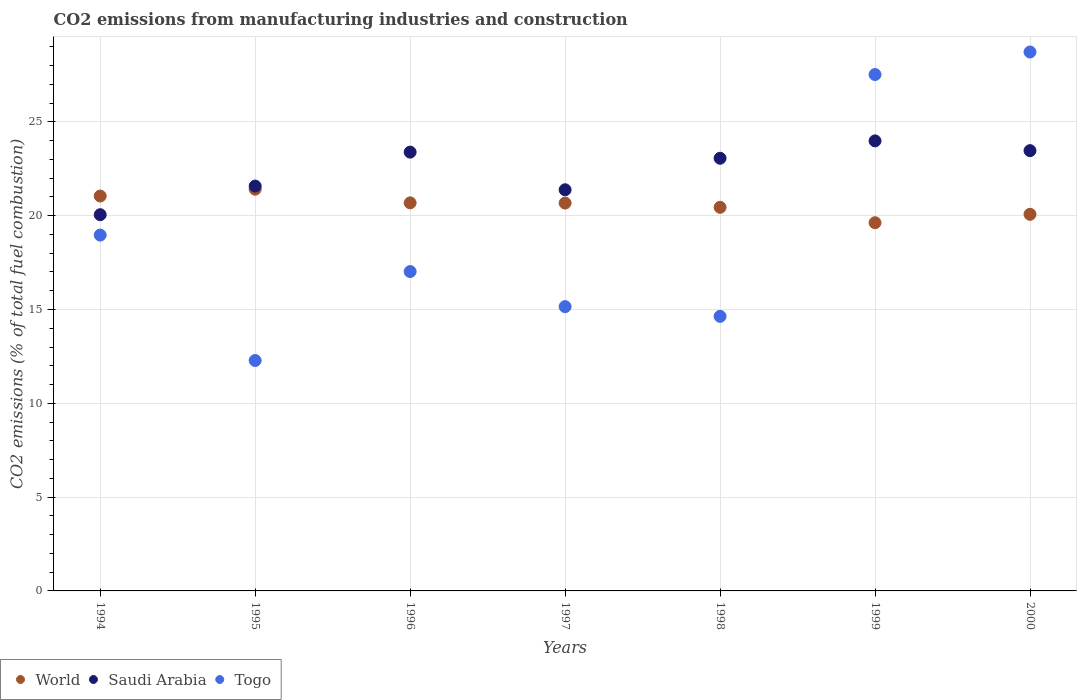What is the amount of CO2 emitted in Saudi Arabia in 1997?
Offer a terse response. 21.38. Across all years, what is the maximum amount of CO2 emitted in World?
Your answer should be very brief. 21.41. Across all years, what is the minimum amount of CO2 emitted in Saudi Arabia?
Your answer should be compact. 20.05. What is the total amount of CO2 emitted in Togo in the graph?
Make the answer very short. 134.3. What is the difference between the amount of CO2 emitted in Saudi Arabia in 1995 and that in 1997?
Your response must be concise. 0.2. What is the difference between the amount of CO2 emitted in Saudi Arabia in 1995 and the amount of CO2 emitted in World in 1999?
Ensure brevity in your answer.  1.95. What is the average amount of CO2 emitted in World per year?
Make the answer very short. 20.56. In the year 1997, what is the difference between the amount of CO2 emitted in Saudi Arabia and amount of CO2 emitted in Togo?
Ensure brevity in your answer.  6.23. In how many years, is the amount of CO2 emitted in Togo greater than 4 %?
Your answer should be compact. 7. What is the ratio of the amount of CO2 emitted in World in 1994 to that in 1997?
Keep it short and to the point. 1.02. Is the amount of CO2 emitted in Saudi Arabia in 1997 less than that in 2000?
Provide a short and direct response. Yes. What is the difference between the highest and the second highest amount of CO2 emitted in Saudi Arabia?
Your response must be concise. 0.52. What is the difference between the highest and the lowest amount of CO2 emitted in World?
Provide a succinct answer. 1.79. Is the sum of the amount of CO2 emitted in Togo in 1994 and 1997 greater than the maximum amount of CO2 emitted in Saudi Arabia across all years?
Provide a short and direct response. Yes. Is the amount of CO2 emitted in Togo strictly less than the amount of CO2 emitted in World over the years?
Your response must be concise. No. How many dotlines are there?
Your answer should be compact. 3. What is the difference between two consecutive major ticks on the Y-axis?
Your response must be concise. 5. Are the values on the major ticks of Y-axis written in scientific E-notation?
Your answer should be very brief. No. Does the graph contain grids?
Your response must be concise. Yes. Where does the legend appear in the graph?
Offer a very short reply. Bottom left. How many legend labels are there?
Your answer should be compact. 3. What is the title of the graph?
Offer a terse response. CO2 emissions from manufacturing industries and construction. What is the label or title of the Y-axis?
Offer a terse response. CO2 emissions (% of total fuel combustion). What is the CO2 emissions (% of total fuel combustion) in World in 1994?
Make the answer very short. 21.05. What is the CO2 emissions (% of total fuel combustion) in Saudi Arabia in 1994?
Your response must be concise. 20.05. What is the CO2 emissions (% of total fuel combustion) of Togo in 1994?
Your response must be concise. 18.97. What is the CO2 emissions (% of total fuel combustion) of World in 1995?
Provide a succinct answer. 21.41. What is the CO2 emissions (% of total fuel combustion) of Saudi Arabia in 1995?
Your response must be concise. 21.58. What is the CO2 emissions (% of total fuel combustion) of Togo in 1995?
Give a very brief answer. 12.28. What is the CO2 emissions (% of total fuel combustion) of World in 1996?
Your answer should be very brief. 20.68. What is the CO2 emissions (% of total fuel combustion) of Saudi Arabia in 1996?
Ensure brevity in your answer.  23.39. What is the CO2 emissions (% of total fuel combustion) in Togo in 1996?
Give a very brief answer. 17.02. What is the CO2 emissions (% of total fuel combustion) of World in 1997?
Your response must be concise. 20.67. What is the CO2 emissions (% of total fuel combustion) in Saudi Arabia in 1997?
Keep it short and to the point. 21.38. What is the CO2 emissions (% of total fuel combustion) in Togo in 1997?
Provide a short and direct response. 15.15. What is the CO2 emissions (% of total fuel combustion) in World in 1998?
Give a very brief answer. 20.45. What is the CO2 emissions (% of total fuel combustion) of Saudi Arabia in 1998?
Ensure brevity in your answer.  23.06. What is the CO2 emissions (% of total fuel combustion) of Togo in 1998?
Keep it short and to the point. 14.63. What is the CO2 emissions (% of total fuel combustion) in World in 1999?
Ensure brevity in your answer.  19.62. What is the CO2 emissions (% of total fuel combustion) in Saudi Arabia in 1999?
Make the answer very short. 23.99. What is the CO2 emissions (% of total fuel combustion) in Togo in 1999?
Provide a short and direct response. 27.52. What is the CO2 emissions (% of total fuel combustion) of World in 2000?
Your answer should be compact. 20.07. What is the CO2 emissions (% of total fuel combustion) of Saudi Arabia in 2000?
Provide a succinct answer. 23.47. What is the CO2 emissions (% of total fuel combustion) in Togo in 2000?
Provide a short and direct response. 28.72. Across all years, what is the maximum CO2 emissions (% of total fuel combustion) in World?
Your response must be concise. 21.41. Across all years, what is the maximum CO2 emissions (% of total fuel combustion) of Saudi Arabia?
Provide a succinct answer. 23.99. Across all years, what is the maximum CO2 emissions (% of total fuel combustion) in Togo?
Your response must be concise. 28.72. Across all years, what is the minimum CO2 emissions (% of total fuel combustion) of World?
Your answer should be very brief. 19.62. Across all years, what is the minimum CO2 emissions (% of total fuel combustion) of Saudi Arabia?
Provide a succinct answer. 20.05. Across all years, what is the minimum CO2 emissions (% of total fuel combustion) in Togo?
Your answer should be very brief. 12.28. What is the total CO2 emissions (% of total fuel combustion) of World in the graph?
Your answer should be compact. 143.95. What is the total CO2 emissions (% of total fuel combustion) in Saudi Arabia in the graph?
Give a very brief answer. 156.91. What is the total CO2 emissions (% of total fuel combustion) of Togo in the graph?
Ensure brevity in your answer.  134.3. What is the difference between the CO2 emissions (% of total fuel combustion) of World in 1994 and that in 1995?
Your answer should be compact. -0.36. What is the difference between the CO2 emissions (% of total fuel combustion) of Saudi Arabia in 1994 and that in 1995?
Offer a terse response. -1.53. What is the difference between the CO2 emissions (% of total fuel combustion) of Togo in 1994 and that in 1995?
Provide a succinct answer. 6.68. What is the difference between the CO2 emissions (% of total fuel combustion) of World in 1994 and that in 1996?
Give a very brief answer. 0.36. What is the difference between the CO2 emissions (% of total fuel combustion) of Saudi Arabia in 1994 and that in 1996?
Your response must be concise. -3.34. What is the difference between the CO2 emissions (% of total fuel combustion) in Togo in 1994 and that in 1996?
Ensure brevity in your answer.  1.94. What is the difference between the CO2 emissions (% of total fuel combustion) of World in 1994 and that in 1997?
Offer a very short reply. 0.37. What is the difference between the CO2 emissions (% of total fuel combustion) in Saudi Arabia in 1994 and that in 1997?
Your response must be concise. -1.33. What is the difference between the CO2 emissions (% of total fuel combustion) in Togo in 1994 and that in 1997?
Provide a succinct answer. 3.81. What is the difference between the CO2 emissions (% of total fuel combustion) of World in 1994 and that in 1998?
Provide a succinct answer. 0.6. What is the difference between the CO2 emissions (% of total fuel combustion) in Saudi Arabia in 1994 and that in 1998?
Provide a short and direct response. -3.01. What is the difference between the CO2 emissions (% of total fuel combustion) in Togo in 1994 and that in 1998?
Provide a short and direct response. 4.33. What is the difference between the CO2 emissions (% of total fuel combustion) in World in 1994 and that in 1999?
Offer a terse response. 1.42. What is the difference between the CO2 emissions (% of total fuel combustion) of Saudi Arabia in 1994 and that in 1999?
Offer a terse response. -3.93. What is the difference between the CO2 emissions (% of total fuel combustion) of Togo in 1994 and that in 1999?
Your answer should be compact. -8.56. What is the difference between the CO2 emissions (% of total fuel combustion) in Saudi Arabia in 1994 and that in 2000?
Keep it short and to the point. -3.41. What is the difference between the CO2 emissions (% of total fuel combustion) of Togo in 1994 and that in 2000?
Provide a succinct answer. -9.76. What is the difference between the CO2 emissions (% of total fuel combustion) of World in 1995 and that in 1996?
Your response must be concise. 0.73. What is the difference between the CO2 emissions (% of total fuel combustion) in Saudi Arabia in 1995 and that in 1996?
Ensure brevity in your answer.  -1.81. What is the difference between the CO2 emissions (% of total fuel combustion) in Togo in 1995 and that in 1996?
Provide a short and direct response. -4.74. What is the difference between the CO2 emissions (% of total fuel combustion) in World in 1995 and that in 1997?
Offer a terse response. 0.74. What is the difference between the CO2 emissions (% of total fuel combustion) in Saudi Arabia in 1995 and that in 1997?
Ensure brevity in your answer.  0.2. What is the difference between the CO2 emissions (% of total fuel combustion) in Togo in 1995 and that in 1997?
Your response must be concise. -2.87. What is the difference between the CO2 emissions (% of total fuel combustion) of World in 1995 and that in 1998?
Your answer should be compact. 0.96. What is the difference between the CO2 emissions (% of total fuel combustion) in Saudi Arabia in 1995 and that in 1998?
Your answer should be very brief. -1.48. What is the difference between the CO2 emissions (% of total fuel combustion) in Togo in 1995 and that in 1998?
Provide a succinct answer. -2.35. What is the difference between the CO2 emissions (% of total fuel combustion) of World in 1995 and that in 1999?
Provide a short and direct response. 1.79. What is the difference between the CO2 emissions (% of total fuel combustion) of Saudi Arabia in 1995 and that in 1999?
Make the answer very short. -2.41. What is the difference between the CO2 emissions (% of total fuel combustion) in Togo in 1995 and that in 1999?
Provide a short and direct response. -15.24. What is the difference between the CO2 emissions (% of total fuel combustion) in World in 1995 and that in 2000?
Offer a very short reply. 1.34. What is the difference between the CO2 emissions (% of total fuel combustion) of Saudi Arabia in 1995 and that in 2000?
Provide a short and direct response. -1.89. What is the difference between the CO2 emissions (% of total fuel combustion) in Togo in 1995 and that in 2000?
Give a very brief answer. -16.44. What is the difference between the CO2 emissions (% of total fuel combustion) in World in 1996 and that in 1997?
Offer a very short reply. 0.01. What is the difference between the CO2 emissions (% of total fuel combustion) in Saudi Arabia in 1996 and that in 1997?
Provide a short and direct response. 2.01. What is the difference between the CO2 emissions (% of total fuel combustion) of Togo in 1996 and that in 1997?
Provide a short and direct response. 1.87. What is the difference between the CO2 emissions (% of total fuel combustion) in World in 1996 and that in 1998?
Offer a very short reply. 0.24. What is the difference between the CO2 emissions (% of total fuel combustion) of Saudi Arabia in 1996 and that in 1998?
Offer a terse response. 0.33. What is the difference between the CO2 emissions (% of total fuel combustion) in Togo in 1996 and that in 1998?
Give a very brief answer. 2.39. What is the difference between the CO2 emissions (% of total fuel combustion) in World in 1996 and that in 1999?
Your response must be concise. 1.06. What is the difference between the CO2 emissions (% of total fuel combustion) in Saudi Arabia in 1996 and that in 1999?
Offer a terse response. -0.6. What is the difference between the CO2 emissions (% of total fuel combustion) in Togo in 1996 and that in 1999?
Offer a very short reply. -10.5. What is the difference between the CO2 emissions (% of total fuel combustion) in World in 1996 and that in 2000?
Your answer should be compact. 0.61. What is the difference between the CO2 emissions (% of total fuel combustion) of Saudi Arabia in 1996 and that in 2000?
Ensure brevity in your answer.  -0.08. What is the difference between the CO2 emissions (% of total fuel combustion) in Togo in 1996 and that in 2000?
Keep it short and to the point. -11.7. What is the difference between the CO2 emissions (% of total fuel combustion) in World in 1997 and that in 1998?
Make the answer very short. 0.23. What is the difference between the CO2 emissions (% of total fuel combustion) in Saudi Arabia in 1997 and that in 1998?
Make the answer very short. -1.68. What is the difference between the CO2 emissions (% of total fuel combustion) in Togo in 1997 and that in 1998?
Keep it short and to the point. 0.52. What is the difference between the CO2 emissions (% of total fuel combustion) of World in 1997 and that in 1999?
Offer a very short reply. 1.05. What is the difference between the CO2 emissions (% of total fuel combustion) in Saudi Arabia in 1997 and that in 1999?
Your answer should be very brief. -2.61. What is the difference between the CO2 emissions (% of total fuel combustion) in Togo in 1997 and that in 1999?
Provide a succinct answer. -12.37. What is the difference between the CO2 emissions (% of total fuel combustion) in World in 1997 and that in 2000?
Your response must be concise. 0.6. What is the difference between the CO2 emissions (% of total fuel combustion) in Saudi Arabia in 1997 and that in 2000?
Provide a short and direct response. -2.09. What is the difference between the CO2 emissions (% of total fuel combustion) of Togo in 1997 and that in 2000?
Make the answer very short. -13.57. What is the difference between the CO2 emissions (% of total fuel combustion) of World in 1998 and that in 1999?
Make the answer very short. 0.82. What is the difference between the CO2 emissions (% of total fuel combustion) of Saudi Arabia in 1998 and that in 1999?
Your answer should be very brief. -0.93. What is the difference between the CO2 emissions (% of total fuel combustion) in Togo in 1998 and that in 1999?
Ensure brevity in your answer.  -12.89. What is the difference between the CO2 emissions (% of total fuel combustion) in World in 1998 and that in 2000?
Your response must be concise. 0.37. What is the difference between the CO2 emissions (% of total fuel combustion) of Saudi Arabia in 1998 and that in 2000?
Your answer should be compact. -0.41. What is the difference between the CO2 emissions (% of total fuel combustion) in Togo in 1998 and that in 2000?
Your response must be concise. -14.09. What is the difference between the CO2 emissions (% of total fuel combustion) in World in 1999 and that in 2000?
Offer a very short reply. -0.45. What is the difference between the CO2 emissions (% of total fuel combustion) in Saudi Arabia in 1999 and that in 2000?
Your answer should be very brief. 0.52. What is the difference between the CO2 emissions (% of total fuel combustion) of Togo in 1999 and that in 2000?
Offer a terse response. -1.2. What is the difference between the CO2 emissions (% of total fuel combustion) of World in 1994 and the CO2 emissions (% of total fuel combustion) of Saudi Arabia in 1995?
Provide a short and direct response. -0.53. What is the difference between the CO2 emissions (% of total fuel combustion) of World in 1994 and the CO2 emissions (% of total fuel combustion) of Togo in 1995?
Offer a very short reply. 8.77. What is the difference between the CO2 emissions (% of total fuel combustion) in Saudi Arabia in 1994 and the CO2 emissions (% of total fuel combustion) in Togo in 1995?
Make the answer very short. 7.77. What is the difference between the CO2 emissions (% of total fuel combustion) in World in 1994 and the CO2 emissions (% of total fuel combustion) in Saudi Arabia in 1996?
Your response must be concise. -2.34. What is the difference between the CO2 emissions (% of total fuel combustion) of World in 1994 and the CO2 emissions (% of total fuel combustion) of Togo in 1996?
Provide a succinct answer. 4.02. What is the difference between the CO2 emissions (% of total fuel combustion) in Saudi Arabia in 1994 and the CO2 emissions (% of total fuel combustion) in Togo in 1996?
Give a very brief answer. 3.03. What is the difference between the CO2 emissions (% of total fuel combustion) of World in 1994 and the CO2 emissions (% of total fuel combustion) of Saudi Arabia in 1997?
Your response must be concise. -0.33. What is the difference between the CO2 emissions (% of total fuel combustion) of World in 1994 and the CO2 emissions (% of total fuel combustion) of Togo in 1997?
Make the answer very short. 5.89. What is the difference between the CO2 emissions (% of total fuel combustion) in Saudi Arabia in 1994 and the CO2 emissions (% of total fuel combustion) in Togo in 1997?
Offer a very short reply. 4.9. What is the difference between the CO2 emissions (% of total fuel combustion) in World in 1994 and the CO2 emissions (% of total fuel combustion) in Saudi Arabia in 1998?
Offer a very short reply. -2.01. What is the difference between the CO2 emissions (% of total fuel combustion) of World in 1994 and the CO2 emissions (% of total fuel combustion) of Togo in 1998?
Your answer should be compact. 6.41. What is the difference between the CO2 emissions (% of total fuel combustion) of Saudi Arabia in 1994 and the CO2 emissions (% of total fuel combustion) of Togo in 1998?
Offer a terse response. 5.42. What is the difference between the CO2 emissions (% of total fuel combustion) in World in 1994 and the CO2 emissions (% of total fuel combustion) in Saudi Arabia in 1999?
Provide a succinct answer. -2.94. What is the difference between the CO2 emissions (% of total fuel combustion) in World in 1994 and the CO2 emissions (% of total fuel combustion) in Togo in 1999?
Your response must be concise. -6.48. What is the difference between the CO2 emissions (% of total fuel combustion) in Saudi Arabia in 1994 and the CO2 emissions (% of total fuel combustion) in Togo in 1999?
Keep it short and to the point. -7.47. What is the difference between the CO2 emissions (% of total fuel combustion) of World in 1994 and the CO2 emissions (% of total fuel combustion) of Saudi Arabia in 2000?
Your answer should be compact. -2.42. What is the difference between the CO2 emissions (% of total fuel combustion) in World in 1994 and the CO2 emissions (% of total fuel combustion) in Togo in 2000?
Offer a terse response. -7.68. What is the difference between the CO2 emissions (% of total fuel combustion) in Saudi Arabia in 1994 and the CO2 emissions (% of total fuel combustion) in Togo in 2000?
Ensure brevity in your answer.  -8.67. What is the difference between the CO2 emissions (% of total fuel combustion) in World in 1995 and the CO2 emissions (% of total fuel combustion) in Saudi Arabia in 1996?
Provide a succinct answer. -1.98. What is the difference between the CO2 emissions (% of total fuel combustion) of World in 1995 and the CO2 emissions (% of total fuel combustion) of Togo in 1996?
Give a very brief answer. 4.39. What is the difference between the CO2 emissions (% of total fuel combustion) of Saudi Arabia in 1995 and the CO2 emissions (% of total fuel combustion) of Togo in 1996?
Your answer should be very brief. 4.56. What is the difference between the CO2 emissions (% of total fuel combustion) of World in 1995 and the CO2 emissions (% of total fuel combustion) of Saudi Arabia in 1997?
Make the answer very short. 0.03. What is the difference between the CO2 emissions (% of total fuel combustion) of World in 1995 and the CO2 emissions (% of total fuel combustion) of Togo in 1997?
Ensure brevity in your answer.  6.26. What is the difference between the CO2 emissions (% of total fuel combustion) of Saudi Arabia in 1995 and the CO2 emissions (% of total fuel combustion) of Togo in 1997?
Keep it short and to the point. 6.43. What is the difference between the CO2 emissions (% of total fuel combustion) of World in 1995 and the CO2 emissions (% of total fuel combustion) of Saudi Arabia in 1998?
Keep it short and to the point. -1.65. What is the difference between the CO2 emissions (% of total fuel combustion) in World in 1995 and the CO2 emissions (% of total fuel combustion) in Togo in 1998?
Your answer should be compact. 6.78. What is the difference between the CO2 emissions (% of total fuel combustion) in Saudi Arabia in 1995 and the CO2 emissions (% of total fuel combustion) in Togo in 1998?
Your response must be concise. 6.94. What is the difference between the CO2 emissions (% of total fuel combustion) in World in 1995 and the CO2 emissions (% of total fuel combustion) in Saudi Arabia in 1999?
Offer a very short reply. -2.58. What is the difference between the CO2 emissions (% of total fuel combustion) in World in 1995 and the CO2 emissions (% of total fuel combustion) in Togo in 1999?
Make the answer very short. -6.11. What is the difference between the CO2 emissions (% of total fuel combustion) in Saudi Arabia in 1995 and the CO2 emissions (% of total fuel combustion) in Togo in 1999?
Your response must be concise. -5.95. What is the difference between the CO2 emissions (% of total fuel combustion) of World in 1995 and the CO2 emissions (% of total fuel combustion) of Saudi Arabia in 2000?
Offer a terse response. -2.05. What is the difference between the CO2 emissions (% of total fuel combustion) of World in 1995 and the CO2 emissions (% of total fuel combustion) of Togo in 2000?
Keep it short and to the point. -7.31. What is the difference between the CO2 emissions (% of total fuel combustion) in Saudi Arabia in 1995 and the CO2 emissions (% of total fuel combustion) in Togo in 2000?
Ensure brevity in your answer.  -7.15. What is the difference between the CO2 emissions (% of total fuel combustion) of World in 1996 and the CO2 emissions (% of total fuel combustion) of Saudi Arabia in 1997?
Keep it short and to the point. -0.7. What is the difference between the CO2 emissions (% of total fuel combustion) in World in 1996 and the CO2 emissions (% of total fuel combustion) in Togo in 1997?
Ensure brevity in your answer.  5.53. What is the difference between the CO2 emissions (% of total fuel combustion) in Saudi Arabia in 1996 and the CO2 emissions (% of total fuel combustion) in Togo in 1997?
Make the answer very short. 8.24. What is the difference between the CO2 emissions (% of total fuel combustion) in World in 1996 and the CO2 emissions (% of total fuel combustion) in Saudi Arabia in 1998?
Your answer should be compact. -2.38. What is the difference between the CO2 emissions (% of total fuel combustion) of World in 1996 and the CO2 emissions (% of total fuel combustion) of Togo in 1998?
Keep it short and to the point. 6.05. What is the difference between the CO2 emissions (% of total fuel combustion) of Saudi Arabia in 1996 and the CO2 emissions (% of total fuel combustion) of Togo in 1998?
Your answer should be very brief. 8.75. What is the difference between the CO2 emissions (% of total fuel combustion) of World in 1996 and the CO2 emissions (% of total fuel combustion) of Saudi Arabia in 1999?
Offer a very short reply. -3.3. What is the difference between the CO2 emissions (% of total fuel combustion) of World in 1996 and the CO2 emissions (% of total fuel combustion) of Togo in 1999?
Your answer should be very brief. -6.84. What is the difference between the CO2 emissions (% of total fuel combustion) of Saudi Arabia in 1996 and the CO2 emissions (% of total fuel combustion) of Togo in 1999?
Your answer should be very brief. -4.14. What is the difference between the CO2 emissions (% of total fuel combustion) of World in 1996 and the CO2 emissions (% of total fuel combustion) of Saudi Arabia in 2000?
Keep it short and to the point. -2.78. What is the difference between the CO2 emissions (% of total fuel combustion) of World in 1996 and the CO2 emissions (% of total fuel combustion) of Togo in 2000?
Ensure brevity in your answer.  -8.04. What is the difference between the CO2 emissions (% of total fuel combustion) in Saudi Arabia in 1996 and the CO2 emissions (% of total fuel combustion) in Togo in 2000?
Make the answer very short. -5.34. What is the difference between the CO2 emissions (% of total fuel combustion) in World in 1997 and the CO2 emissions (% of total fuel combustion) in Saudi Arabia in 1998?
Ensure brevity in your answer.  -2.39. What is the difference between the CO2 emissions (% of total fuel combustion) of World in 1997 and the CO2 emissions (% of total fuel combustion) of Togo in 1998?
Your answer should be compact. 6.04. What is the difference between the CO2 emissions (% of total fuel combustion) in Saudi Arabia in 1997 and the CO2 emissions (% of total fuel combustion) in Togo in 1998?
Your answer should be very brief. 6.75. What is the difference between the CO2 emissions (% of total fuel combustion) in World in 1997 and the CO2 emissions (% of total fuel combustion) in Saudi Arabia in 1999?
Make the answer very short. -3.31. What is the difference between the CO2 emissions (% of total fuel combustion) of World in 1997 and the CO2 emissions (% of total fuel combustion) of Togo in 1999?
Provide a short and direct response. -6.85. What is the difference between the CO2 emissions (% of total fuel combustion) in Saudi Arabia in 1997 and the CO2 emissions (% of total fuel combustion) in Togo in 1999?
Your answer should be compact. -6.14. What is the difference between the CO2 emissions (% of total fuel combustion) in World in 1997 and the CO2 emissions (% of total fuel combustion) in Saudi Arabia in 2000?
Your response must be concise. -2.79. What is the difference between the CO2 emissions (% of total fuel combustion) in World in 1997 and the CO2 emissions (% of total fuel combustion) in Togo in 2000?
Your response must be concise. -8.05. What is the difference between the CO2 emissions (% of total fuel combustion) of Saudi Arabia in 1997 and the CO2 emissions (% of total fuel combustion) of Togo in 2000?
Keep it short and to the point. -7.34. What is the difference between the CO2 emissions (% of total fuel combustion) of World in 1998 and the CO2 emissions (% of total fuel combustion) of Saudi Arabia in 1999?
Offer a very short reply. -3.54. What is the difference between the CO2 emissions (% of total fuel combustion) of World in 1998 and the CO2 emissions (% of total fuel combustion) of Togo in 1999?
Your answer should be very brief. -7.08. What is the difference between the CO2 emissions (% of total fuel combustion) of Saudi Arabia in 1998 and the CO2 emissions (% of total fuel combustion) of Togo in 1999?
Your answer should be compact. -4.46. What is the difference between the CO2 emissions (% of total fuel combustion) of World in 1998 and the CO2 emissions (% of total fuel combustion) of Saudi Arabia in 2000?
Provide a succinct answer. -3.02. What is the difference between the CO2 emissions (% of total fuel combustion) in World in 1998 and the CO2 emissions (% of total fuel combustion) in Togo in 2000?
Your answer should be compact. -8.28. What is the difference between the CO2 emissions (% of total fuel combustion) of Saudi Arabia in 1998 and the CO2 emissions (% of total fuel combustion) of Togo in 2000?
Offer a terse response. -5.66. What is the difference between the CO2 emissions (% of total fuel combustion) of World in 1999 and the CO2 emissions (% of total fuel combustion) of Saudi Arabia in 2000?
Offer a very short reply. -3.84. What is the difference between the CO2 emissions (% of total fuel combustion) in World in 1999 and the CO2 emissions (% of total fuel combustion) in Togo in 2000?
Your answer should be compact. -9.1. What is the difference between the CO2 emissions (% of total fuel combustion) of Saudi Arabia in 1999 and the CO2 emissions (% of total fuel combustion) of Togo in 2000?
Ensure brevity in your answer.  -4.74. What is the average CO2 emissions (% of total fuel combustion) of World per year?
Give a very brief answer. 20.56. What is the average CO2 emissions (% of total fuel combustion) in Saudi Arabia per year?
Give a very brief answer. 22.42. What is the average CO2 emissions (% of total fuel combustion) of Togo per year?
Provide a short and direct response. 19.19. In the year 1994, what is the difference between the CO2 emissions (% of total fuel combustion) in World and CO2 emissions (% of total fuel combustion) in Togo?
Make the answer very short. 2.08. In the year 1994, what is the difference between the CO2 emissions (% of total fuel combustion) in Saudi Arabia and CO2 emissions (% of total fuel combustion) in Togo?
Ensure brevity in your answer.  1.09. In the year 1995, what is the difference between the CO2 emissions (% of total fuel combustion) in World and CO2 emissions (% of total fuel combustion) in Saudi Arabia?
Your answer should be very brief. -0.17. In the year 1995, what is the difference between the CO2 emissions (% of total fuel combustion) in World and CO2 emissions (% of total fuel combustion) in Togo?
Make the answer very short. 9.13. In the year 1995, what is the difference between the CO2 emissions (% of total fuel combustion) in Saudi Arabia and CO2 emissions (% of total fuel combustion) in Togo?
Offer a very short reply. 9.3. In the year 1996, what is the difference between the CO2 emissions (% of total fuel combustion) of World and CO2 emissions (% of total fuel combustion) of Saudi Arabia?
Provide a short and direct response. -2.7. In the year 1996, what is the difference between the CO2 emissions (% of total fuel combustion) in World and CO2 emissions (% of total fuel combustion) in Togo?
Keep it short and to the point. 3.66. In the year 1996, what is the difference between the CO2 emissions (% of total fuel combustion) in Saudi Arabia and CO2 emissions (% of total fuel combustion) in Togo?
Your response must be concise. 6.37. In the year 1997, what is the difference between the CO2 emissions (% of total fuel combustion) of World and CO2 emissions (% of total fuel combustion) of Saudi Arabia?
Keep it short and to the point. -0.71. In the year 1997, what is the difference between the CO2 emissions (% of total fuel combustion) in World and CO2 emissions (% of total fuel combustion) in Togo?
Your answer should be compact. 5.52. In the year 1997, what is the difference between the CO2 emissions (% of total fuel combustion) in Saudi Arabia and CO2 emissions (% of total fuel combustion) in Togo?
Provide a short and direct response. 6.23. In the year 1998, what is the difference between the CO2 emissions (% of total fuel combustion) in World and CO2 emissions (% of total fuel combustion) in Saudi Arabia?
Your answer should be compact. -2.61. In the year 1998, what is the difference between the CO2 emissions (% of total fuel combustion) of World and CO2 emissions (% of total fuel combustion) of Togo?
Offer a very short reply. 5.81. In the year 1998, what is the difference between the CO2 emissions (% of total fuel combustion) of Saudi Arabia and CO2 emissions (% of total fuel combustion) of Togo?
Ensure brevity in your answer.  8.43. In the year 1999, what is the difference between the CO2 emissions (% of total fuel combustion) of World and CO2 emissions (% of total fuel combustion) of Saudi Arabia?
Give a very brief answer. -4.36. In the year 1999, what is the difference between the CO2 emissions (% of total fuel combustion) of World and CO2 emissions (% of total fuel combustion) of Togo?
Your answer should be very brief. -7.9. In the year 1999, what is the difference between the CO2 emissions (% of total fuel combustion) of Saudi Arabia and CO2 emissions (% of total fuel combustion) of Togo?
Your answer should be compact. -3.54. In the year 2000, what is the difference between the CO2 emissions (% of total fuel combustion) in World and CO2 emissions (% of total fuel combustion) in Saudi Arabia?
Make the answer very short. -3.39. In the year 2000, what is the difference between the CO2 emissions (% of total fuel combustion) of World and CO2 emissions (% of total fuel combustion) of Togo?
Your answer should be very brief. -8.65. In the year 2000, what is the difference between the CO2 emissions (% of total fuel combustion) of Saudi Arabia and CO2 emissions (% of total fuel combustion) of Togo?
Your answer should be very brief. -5.26. What is the ratio of the CO2 emissions (% of total fuel combustion) in Saudi Arabia in 1994 to that in 1995?
Ensure brevity in your answer.  0.93. What is the ratio of the CO2 emissions (% of total fuel combustion) of Togo in 1994 to that in 1995?
Provide a short and direct response. 1.54. What is the ratio of the CO2 emissions (% of total fuel combustion) of World in 1994 to that in 1996?
Offer a terse response. 1.02. What is the ratio of the CO2 emissions (% of total fuel combustion) of Saudi Arabia in 1994 to that in 1996?
Make the answer very short. 0.86. What is the ratio of the CO2 emissions (% of total fuel combustion) in Togo in 1994 to that in 1996?
Offer a very short reply. 1.11. What is the ratio of the CO2 emissions (% of total fuel combustion) of World in 1994 to that in 1997?
Your answer should be compact. 1.02. What is the ratio of the CO2 emissions (% of total fuel combustion) in Saudi Arabia in 1994 to that in 1997?
Offer a very short reply. 0.94. What is the ratio of the CO2 emissions (% of total fuel combustion) of Togo in 1994 to that in 1997?
Provide a succinct answer. 1.25. What is the ratio of the CO2 emissions (% of total fuel combustion) in World in 1994 to that in 1998?
Provide a short and direct response. 1.03. What is the ratio of the CO2 emissions (% of total fuel combustion) of Saudi Arabia in 1994 to that in 1998?
Ensure brevity in your answer.  0.87. What is the ratio of the CO2 emissions (% of total fuel combustion) of Togo in 1994 to that in 1998?
Your answer should be very brief. 1.3. What is the ratio of the CO2 emissions (% of total fuel combustion) of World in 1994 to that in 1999?
Keep it short and to the point. 1.07. What is the ratio of the CO2 emissions (% of total fuel combustion) in Saudi Arabia in 1994 to that in 1999?
Your answer should be very brief. 0.84. What is the ratio of the CO2 emissions (% of total fuel combustion) of Togo in 1994 to that in 1999?
Offer a terse response. 0.69. What is the ratio of the CO2 emissions (% of total fuel combustion) in World in 1994 to that in 2000?
Your answer should be very brief. 1.05. What is the ratio of the CO2 emissions (% of total fuel combustion) in Saudi Arabia in 1994 to that in 2000?
Keep it short and to the point. 0.85. What is the ratio of the CO2 emissions (% of total fuel combustion) in Togo in 1994 to that in 2000?
Provide a succinct answer. 0.66. What is the ratio of the CO2 emissions (% of total fuel combustion) in World in 1995 to that in 1996?
Your response must be concise. 1.04. What is the ratio of the CO2 emissions (% of total fuel combustion) of Saudi Arabia in 1995 to that in 1996?
Offer a terse response. 0.92. What is the ratio of the CO2 emissions (% of total fuel combustion) of Togo in 1995 to that in 1996?
Make the answer very short. 0.72. What is the ratio of the CO2 emissions (% of total fuel combustion) of World in 1995 to that in 1997?
Your answer should be compact. 1.04. What is the ratio of the CO2 emissions (% of total fuel combustion) of Saudi Arabia in 1995 to that in 1997?
Ensure brevity in your answer.  1.01. What is the ratio of the CO2 emissions (% of total fuel combustion) of Togo in 1995 to that in 1997?
Your answer should be compact. 0.81. What is the ratio of the CO2 emissions (% of total fuel combustion) of World in 1995 to that in 1998?
Ensure brevity in your answer.  1.05. What is the ratio of the CO2 emissions (% of total fuel combustion) in Saudi Arabia in 1995 to that in 1998?
Offer a terse response. 0.94. What is the ratio of the CO2 emissions (% of total fuel combustion) of Togo in 1995 to that in 1998?
Your answer should be compact. 0.84. What is the ratio of the CO2 emissions (% of total fuel combustion) of World in 1995 to that in 1999?
Offer a terse response. 1.09. What is the ratio of the CO2 emissions (% of total fuel combustion) of Saudi Arabia in 1995 to that in 1999?
Your answer should be very brief. 0.9. What is the ratio of the CO2 emissions (% of total fuel combustion) in Togo in 1995 to that in 1999?
Keep it short and to the point. 0.45. What is the ratio of the CO2 emissions (% of total fuel combustion) in World in 1995 to that in 2000?
Keep it short and to the point. 1.07. What is the ratio of the CO2 emissions (% of total fuel combustion) of Saudi Arabia in 1995 to that in 2000?
Give a very brief answer. 0.92. What is the ratio of the CO2 emissions (% of total fuel combustion) of Togo in 1995 to that in 2000?
Your answer should be very brief. 0.43. What is the ratio of the CO2 emissions (% of total fuel combustion) of World in 1996 to that in 1997?
Provide a succinct answer. 1. What is the ratio of the CO2 emissions (% of total fuel combustion) in Saudi Arabia in 1996 to that in 1997?
Offer a very short reply. 1.09. What is the ratio of the CO2 emissions (% of total fuel combustion) of Togo in 1996 to that in 1997?
Make the answer very short. 1.12. What is the ratio of the CO2 emissions (% of total fuel combustion) of World in 1996 to that in 1998?
Provide a short and direct response. 1.01. What is the ratio of the CO2 emissions (% of total fuel combustion) in Saudi Arabia in 1996 to that in 1998?
Provide a succinct answer. 1.01. What is the ratio of the CO2 emissions (% of total fuel combustion) of Togo in 1996 to that in 1998?
Offer a terse response. 1.16. What is the ratio of the CO2 emissions (% of total fuel combustion) in World in 1996 to that in 1999?
Offer a very short reply. 1.05. What is the ratio of the CO2 emissions (% of total fuel combustion) in Togo in 1996 to that in 1999?
Offer a terse response. 0.62. What is the ratio of the CO2 emissions (% of total fuel combustion) in World in 1996 to that in 2000?
Provide a short and direct response. 1.03. What is the ratio of the CO2 emissions (% of total fuel combustion) in Togo in 1996 to that in 2000?
Provide a short and direct response. 0.59. What is the ratio of the CO2 emissions (% of total fuel combustion) of World in 1997 to that in 1998?
Give a very brief answer. 1.01. What is the ratio of the CO2 emissions (% of total fuel combustion) of Saudi Arabia in 1997 to that in 1998?
Make the answer very short. 0.93. What is the ratio of the CO2 emissions (% of total fuel combustion) in Togo in 1997 to that in 1998?
Give a very brief answer. 1.04. What is the ratio of the CO2 emissions (% of total fuel combustion) of World in 1997 to that in 1999?
Provide a short and direct response. 1.05. What is the ratio of the CO2 emissions (% of total fuel combustion) in Saudi Arabia in 1997 to that in 1999?
Your answer should be compact. 0.89. What is the ratio of the CO2 emissions (% of total fuel combustion) of Togo in 1997 to that in 1999?
Your response must be concise. 0.55. What is the ratio of the CO2 emissions (% of total fuel combustion) in World in 1997 to that in 2000?
Your response must be concise. 1.03. What is the ratio of the CO2 emissions (% of total fuel combustion) of Saudi Arabia in 1997 to that in 2000?
Provide a succinct answer. 0.91. What is the ratio of the CO2 emissions (% of total fuel combustion) of Togo in 1997 to that in 2000?
Provide a short and direct response. 0.53. What is the ratio of the CO2 emissions (% of total fuel combustion) of World in 1998 to that in 1999?
Provide a short and direct response. 1.04. What is the ratio of the CO2 emissions (% of total fuel combustion) in Saudi Arabia in 1998 to that in 1999?
Your answer should be very brief. 0.96. What is the ratio of the CO2 emissions (% of total fuel combustion) of Togo in 1998 to that in 1999?
Ensure brevity in your answer.  0.53. What is the ratio of the CO2 emissions (% of total fuel combustion) of World in 1998 to that in 2000?
Provide a succinct answer. 1.02. What is the ratio of the CO2 emissions (% of total fuel combustion) of Saudi Arabia in 1998 to that in 2000?
Provide a short and direct response. 0.98. What is the ratio of the CO2 emissions (% of total fuel combustion) in Togo in 1998 to that in 2000?
Provide a succinct answer. 0.51. What is the ratio of the CO2 emissions (% of total fuel combustion) of World in 1999 to that in 2000?
Offer a terse response. 0.98. What is the ratio of the CO2 emissions (% of total fuel combustion) of Saudi Arabia in 1999 to that in 2000?
Your answer should be very brief. 1.02. What is the ratio of the CO2 emissions (% of total fuel combustion) of Togo in 1999 to that in 2000?
Ensure brevity in your answer.  0.96. What is the difference between the highest and the second highest CO2 emissions (% of total fuel combustion) of World?
Make the answer very short. 0.36. What is the difference between the highest and the second highest CO2 emissions (% of total fuel combustion) in Saudi Arabia?
Offer a terse response. 0.52. What is the difference between the highest and the second highest CO2 emissions (% of total fuel combustion) in Togo?
Your answer should be compact. 1.2. What is the difference between the highest and the lowest CO2 emissions (% of total fuel combustion) of World?
Your response must be concise. 1.79. What is the difference between the highest and the lowest CO2 emissions (% of total fuel combustion) of Saudi Arabia?
Provide a short and direct response. 3.93. What is the difference between the highest and the lowest CO2 emissions (% of total fuel combustion) of Togo?
Your answer should be very brief. 16.44. 